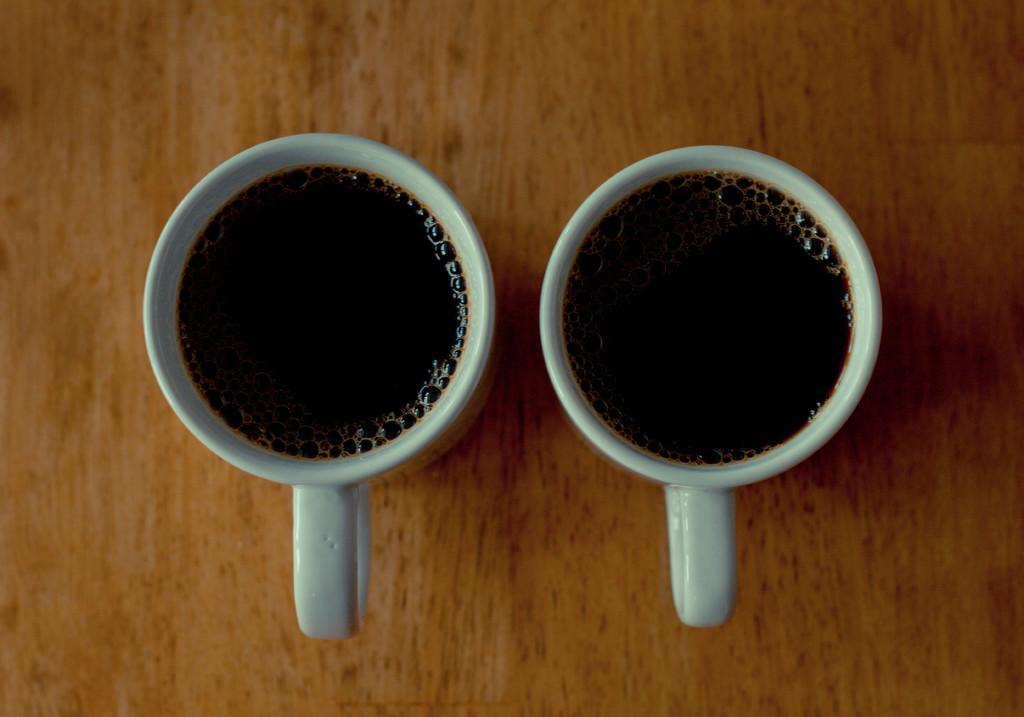In one or two sentences, can you explain what this image depicts? Here we can see two cups with liquid in it on a platform. 